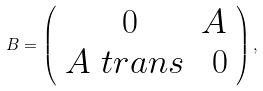Convert formula to latex. <formula><loc_0><loc_0><loc_500><loc_500>B = \left ( \begin{array} { c c } \ 0 & A \\ A \ t r a n s & \ 0 \end{array} \right ) ,</formula> 